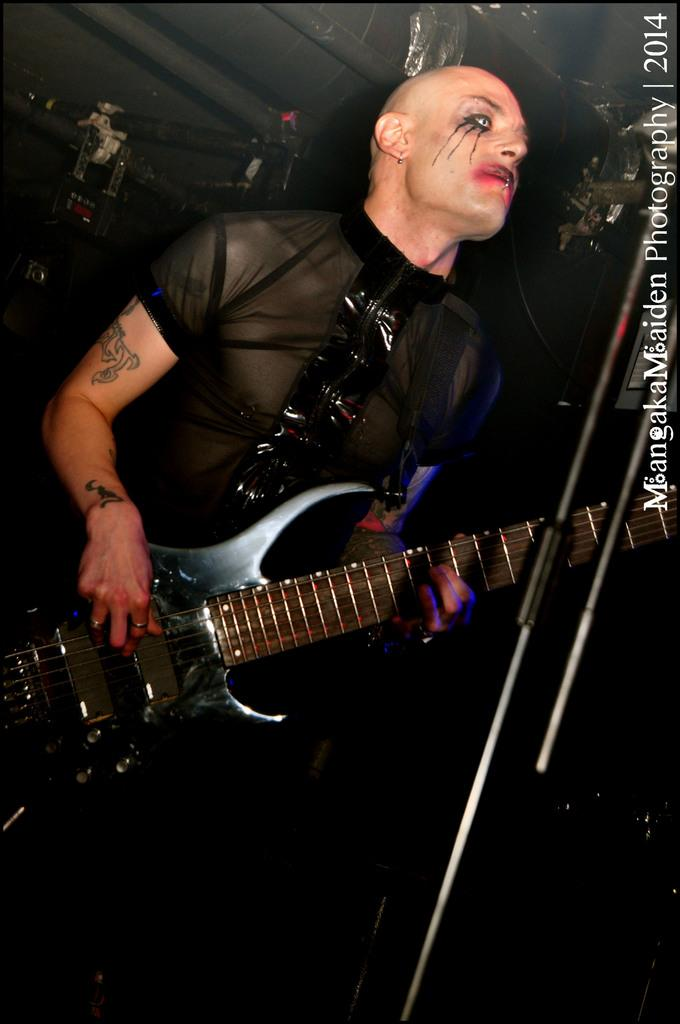What is the person in the image holding? The person is holding a guitar. Can you describe any distinguishing features of the person? The person has a tattoo on their right hand and their face has Halloween decorations. What object is in front of the person? There is a microphone in front of the person. What type of star can be seen on the person's brother's shirt in the image? There is no mention of a brother or a shirt with a star in the provided facts, so we cannot answer this question based on the image. 